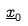<formula> <loc_0><loc_0><loc_500><loc_500>\underline { x } _ { 0 }</formula> 